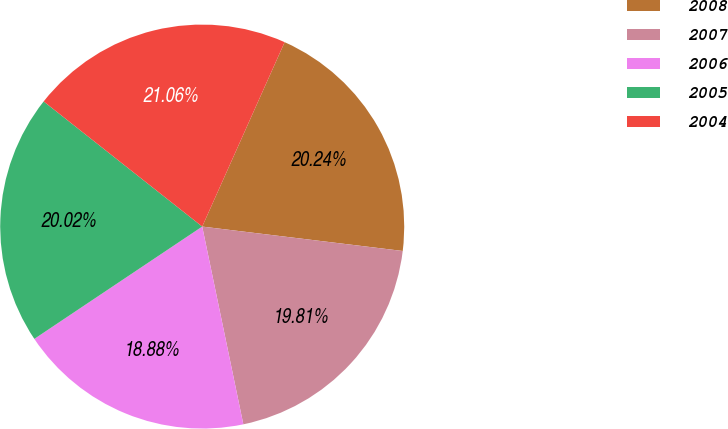Convert chart. <chart><loc_0><loc_0><loc_500><loc_500><pie_chart><fcel>2008<fcel>2007<fcel>2006<fcel>2005<fcel>2004<nl><fcel>20.24%<fcel>19.81%<fcel>18.88%<fcel>20.02%<fcel>21.06%<nl></chart> 